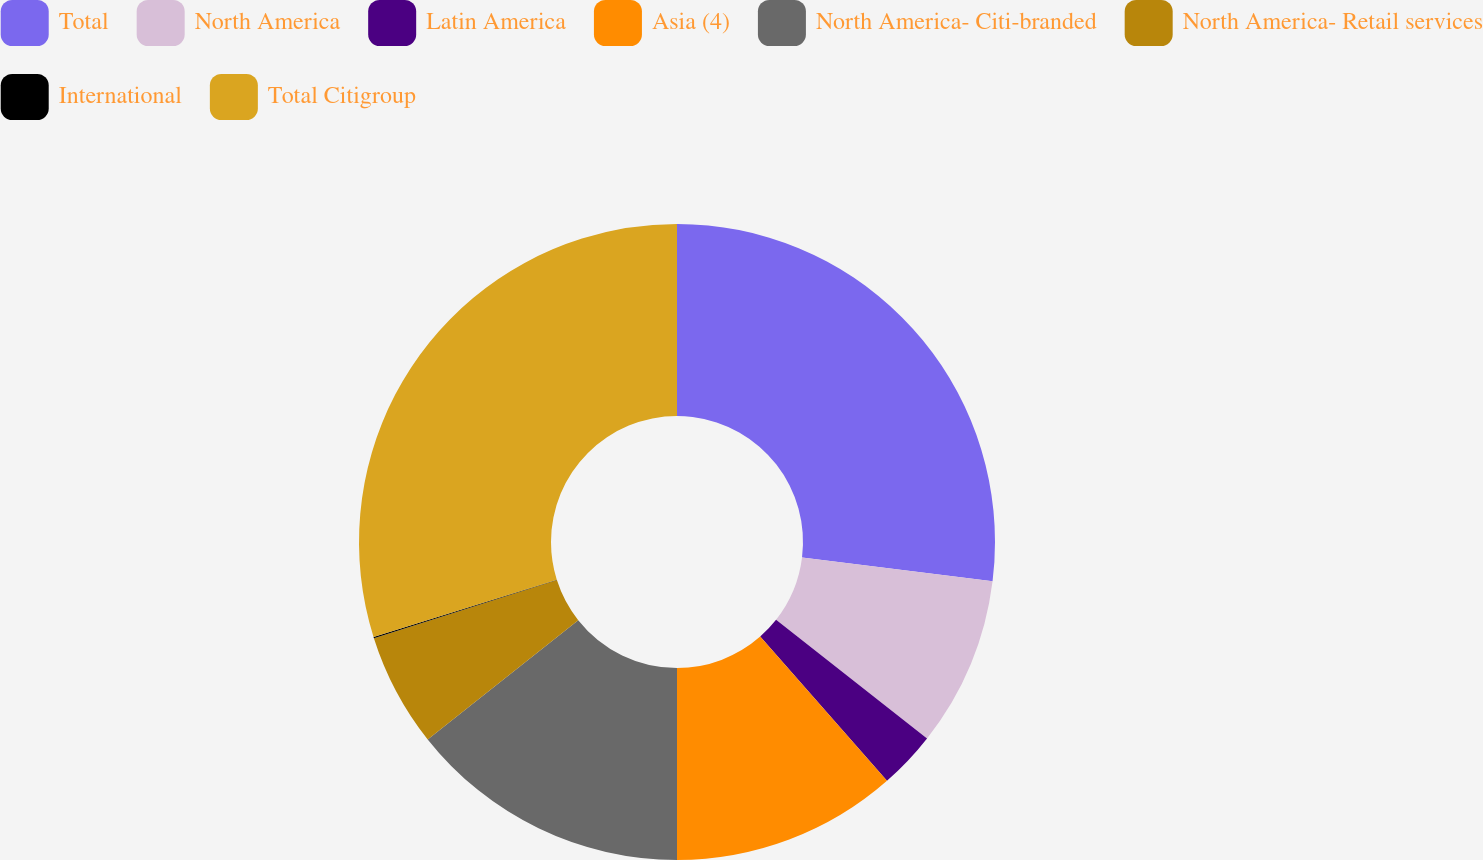Convert chart. <chart><loc_0><loc_0><loc_500><loc_500><pie_chart><fcel>Total<fcel>North America<fcel>Latin America<fcel>Asia (4)<fcel>North America- Citi-branded<fcel>North America- Retail services<fcel>International<fcel>Total Citigroup<nl><fcel>26.97%<fcel>8.63%<fcel>2.92%<fcel>11.48%<fcel>14.34%<fcel>5.77%<fcel>0.06%<fcel>29.83%<nl></chart> 